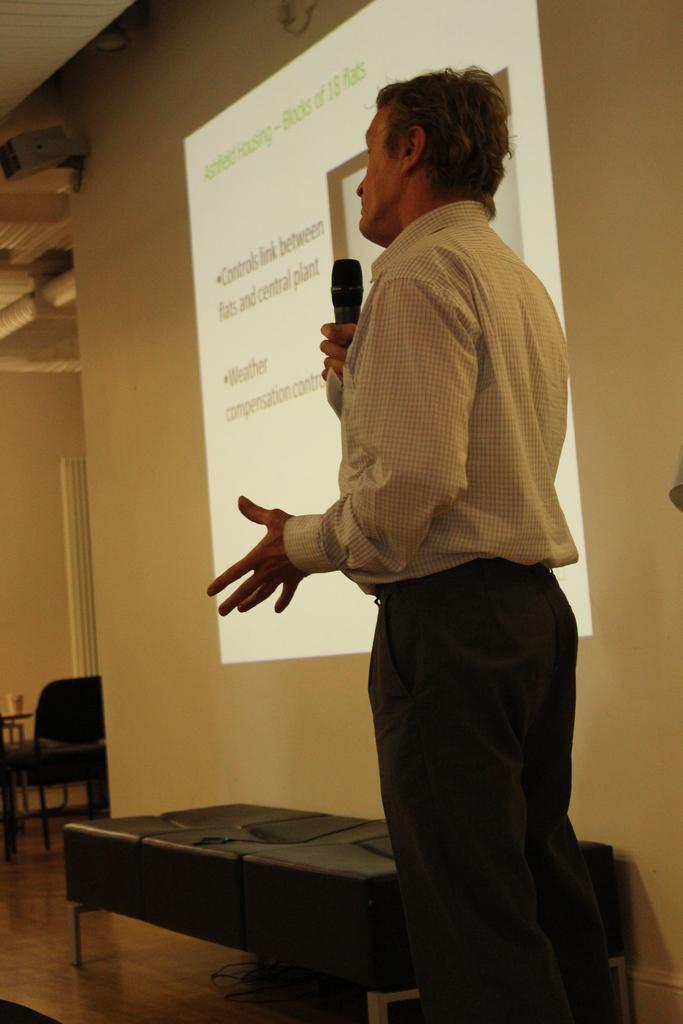What is the man in the image doing? The man is standing and holding a microphone in his hand. What objects can be seen in the background of the image? There is a table, a chair, a glass, a wall, and a screen in the background of the image. What might the man be using the microphone for? The man might be using the microphone for speaking or singing. What type of owl can be seen sitting on the man's shoulder in the image? There is no owl present in the image; the man is holding a microphone. How many lizards are crawling on the wall in the background of the image? There are no lizards present in the image; there is only a wall visible in the background. 